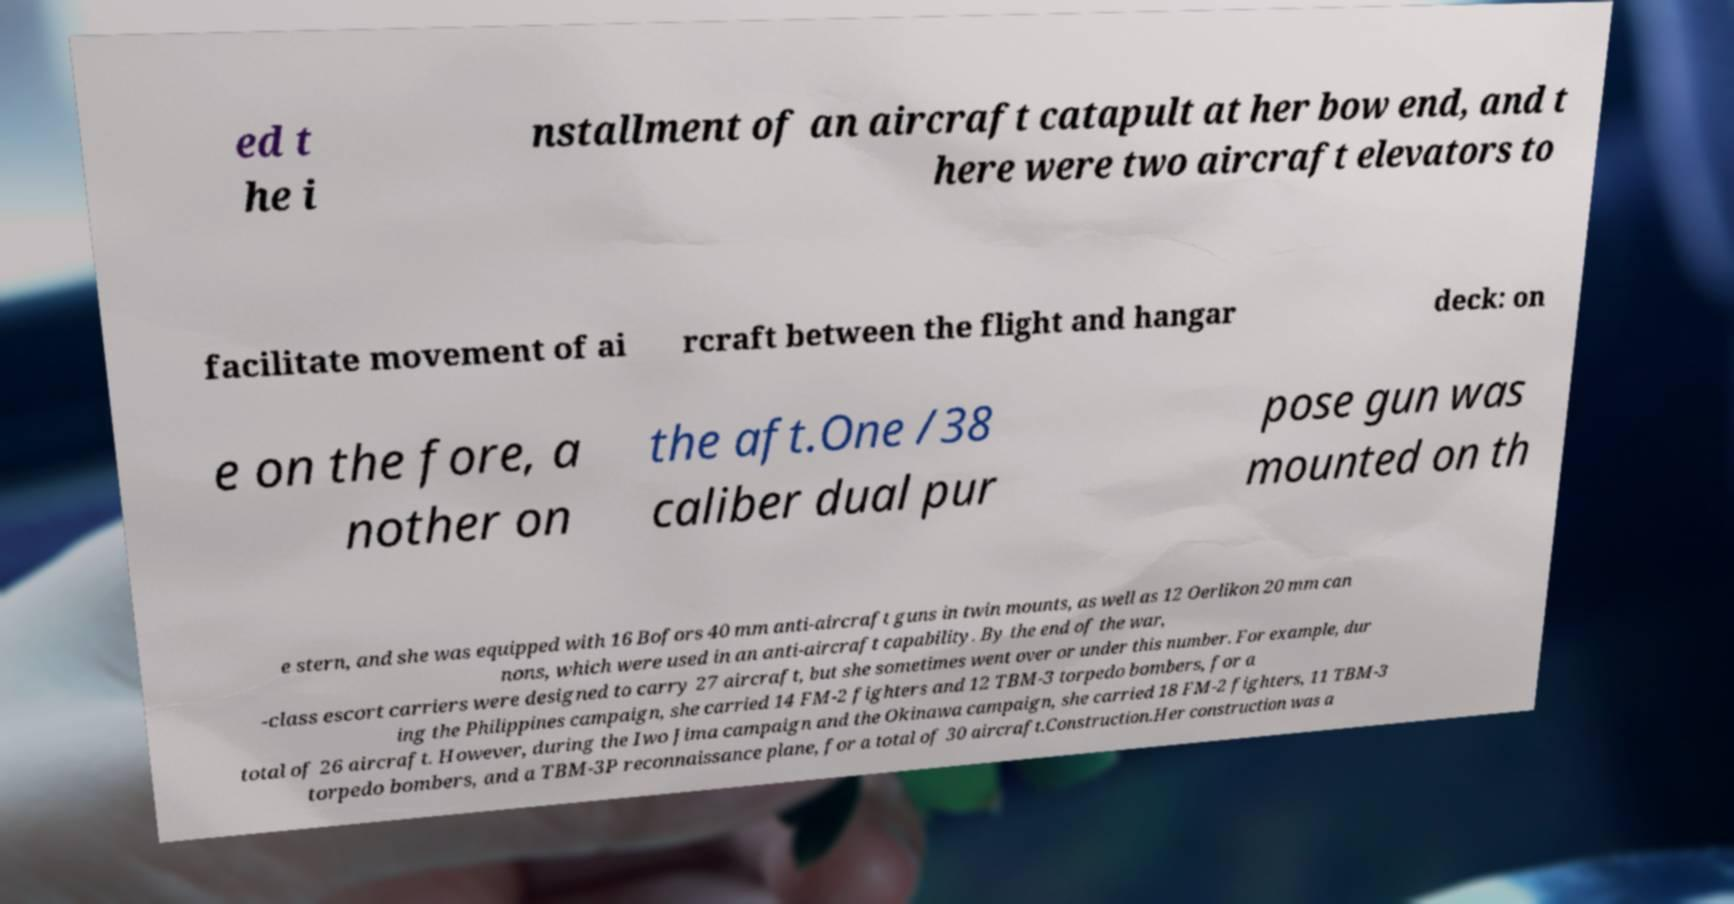For documentation purposes, I need the text within this image transcribed. Could you provide that? ed t he i nstallment of an aircraft catapult at her bow end, and t here were two aircraft elevators to facilitate movement of ai rcraft between the flight and hangar deck: on e on the fore, a nother on the aft.One /38 caliber dual pur pose gun was mounted on th e stern, and she was equipped with 16 Bofors 40 mm anti-aircraft guns in twin mounts, as well as 12 Oerlikon 20 mm can nons, which were used in an anti-aircraft capability. By the end of the war, -class escort carriers were designed to carry 27 aircraft, but she sometimes went over or under this number. For example, dur ing the Philippines campaign, she carried 14 FM-2 fighters and 12 TBM-3 torpedo bombers, for a total of 26 aircraft. However, during the Iwo Jima campaign and the Okinawa campaign, she carried 18 FM-2 fighters, 11 TBM-3 torpedo bombers, and a TBM-3P reconnaissance plane, for a total of 30 aircraft.Construction.Her construction was a 